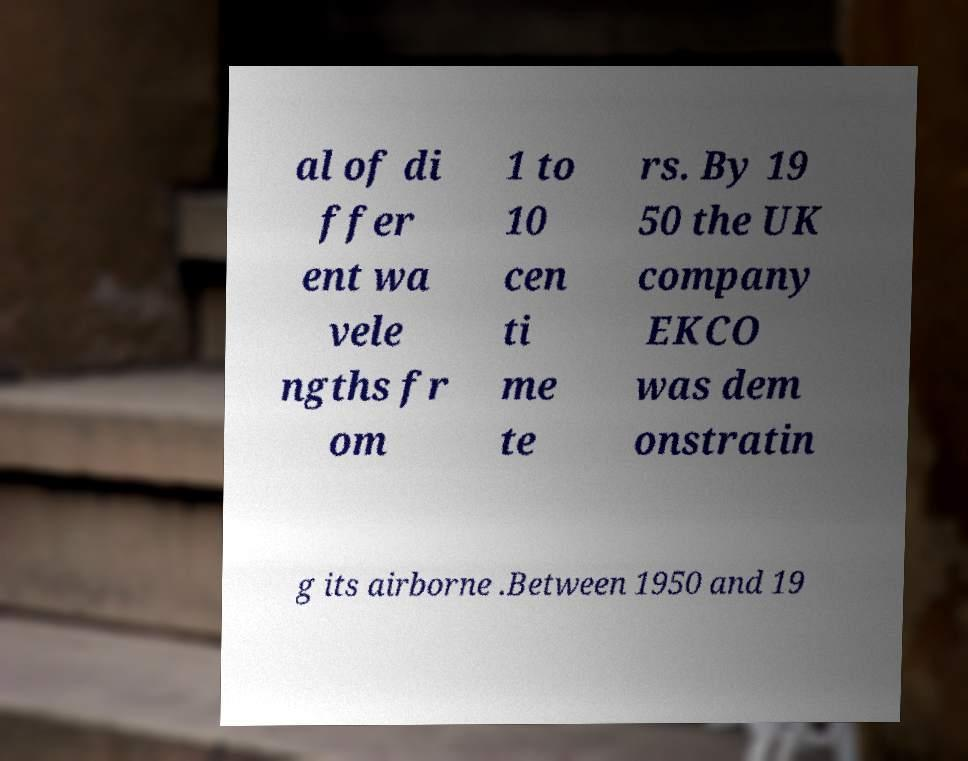Could you assist in decoding the text presented in this image and type it out clearly? al of di ffer ent wa vele ngths fr om 1 to 10 cen ti me te rs. By 19 50 the UK company EKCO was dem onstratin g its airborne .Between 1950 and 19 